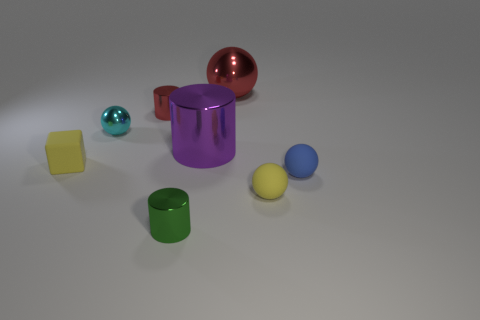Add 1 purple matte spheres. How many objects exist? 9 Subtract all red balls. How many balls are left? 3 Subtract all gray spheres. How many cyan blocks are left? 0 Subtract all red balls. How many balls are left? 3 Subtract all cylinders. How many objects are left? 5 Subtract 1 spheres. How many spheres are left? 3 Subtract all yellow cylinders. Subtract all blue spheres. How many cylinders are left? 3 Subtract all large objects. Subtract all big metal things. How many objects are left? 4 Add 7 metal cylinders. How many metal cylinders are left? 10 Add 4 big red rubber balls. How many big red rubber balls exist? 4 